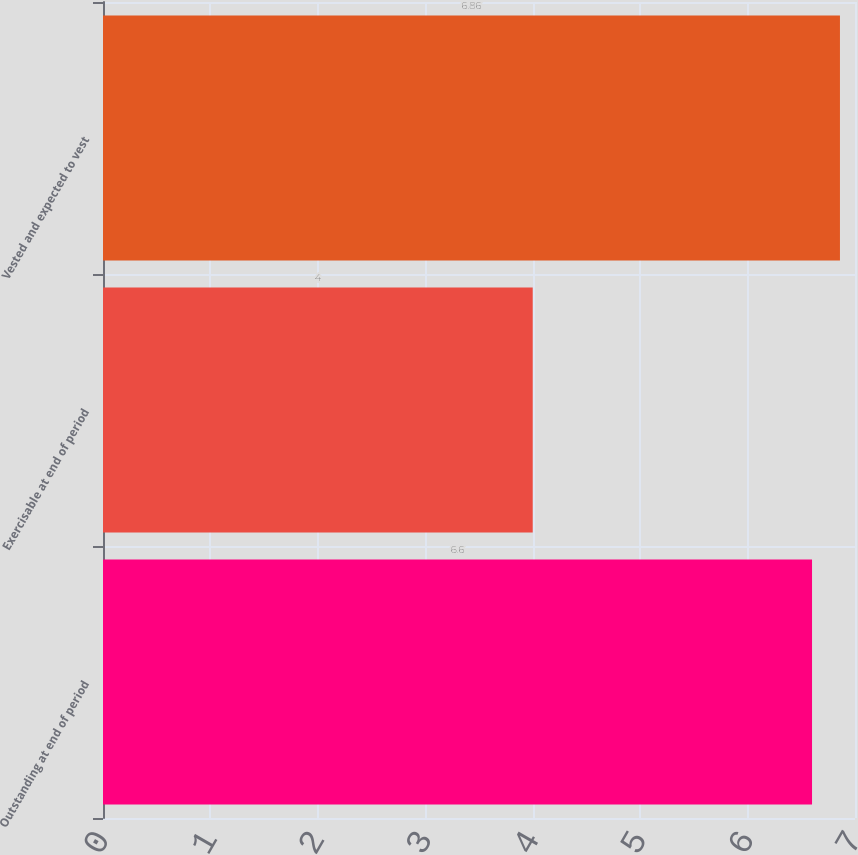<chart> <loc_0><loc_0><loc_500><loc_500><bar_chart><fcel>Outstanding at end of period<fcel>Exercisable at end of period<fcel>Vested and expected to vest<nl><fcel>6.6<fcel>4<fcel>6.86<nl></chart> 